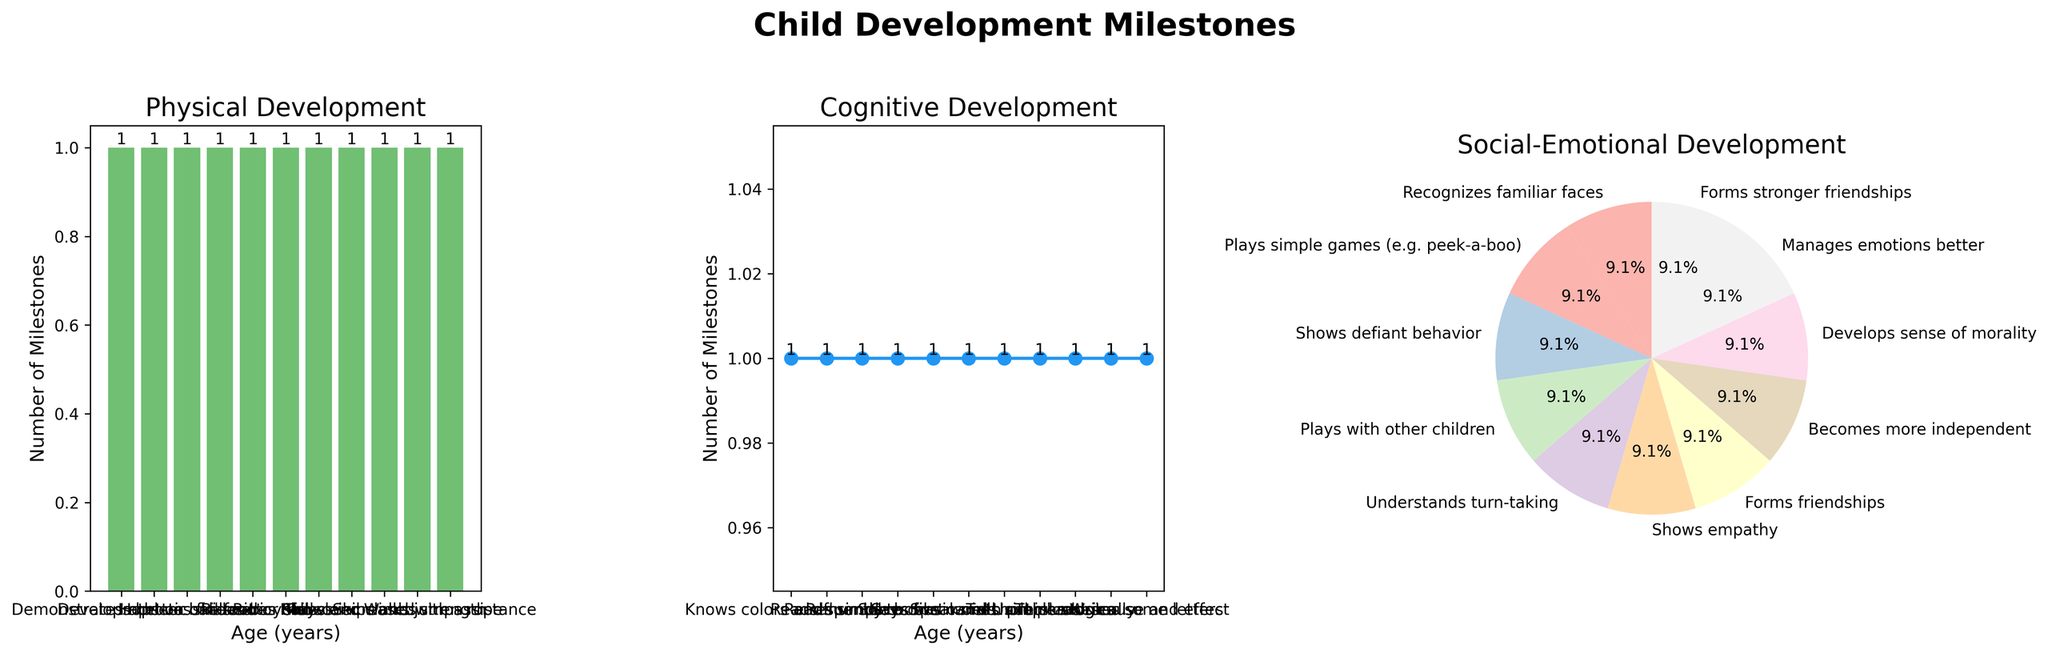What is the title of the entire figure? The title of the figure is prominently displayed at the top. It reads "Child Development Milestones."
Answer: Child Development Milestones What color is used for the bars in the Physical Development bar chart? The bars in the Physical Development bar chart are colored green, which stands out clearly.
Answer: Green How many milestones are shown in the Social-Emotional Development pie chart? By counting the different slices in the pie chart, we find that there are 10 slices shown, each corresponding to a different milestone.
Answer: 10 Which age group has the most milestones in the Physical Development bar chart? Looking at the height of the bars in the Physical Development chart, the age group with the highest bar represents the most milestones.
Answer: 5 years Which chart shows the trend of Cognitive Development milestones over age? The chart trending Cognitive Development milestones over age is a line chart, recognizable by the line connecting data points across different ages.
Answer: Line chart What are the axes labeled in the Physical Development bar chart? The x-axis is labeled "Age (years)," and the y-axis is labeled "Number of Milestones." These labels are located next to the respective axes.
Answer: Age (years), Number of Milestones At what age does the line chart show the highest number of Cognitive Development milestones? Observing the peaks in the line chart, the highest point is at the age corresponding to the most Cognitive Development milestones.
Answer: 6 years Which chart type shows different proportions of Social-Emotional milestones? Different proportions of Social-Emotional milestones are shown using a pie chart, recognized by its circular shape with divided segments.
Answer: Pie chart Compare the number of milestones at ages 2 years and 5 years in the Physical Development chart. Which one is higher? In the Physical Development chart, the bar for age 5 years is higher than the bar for age 2 years, indicating more milestones.
Answer: 5 years Between age groups 3 years and 6 years, which has more Cognitive Development milestones according to the line chart? By comparing the height of points on the line chart, the point at 6 years is higher than at 3 years, indicating more Cognitive Development milestones.
Answer: 6 years 